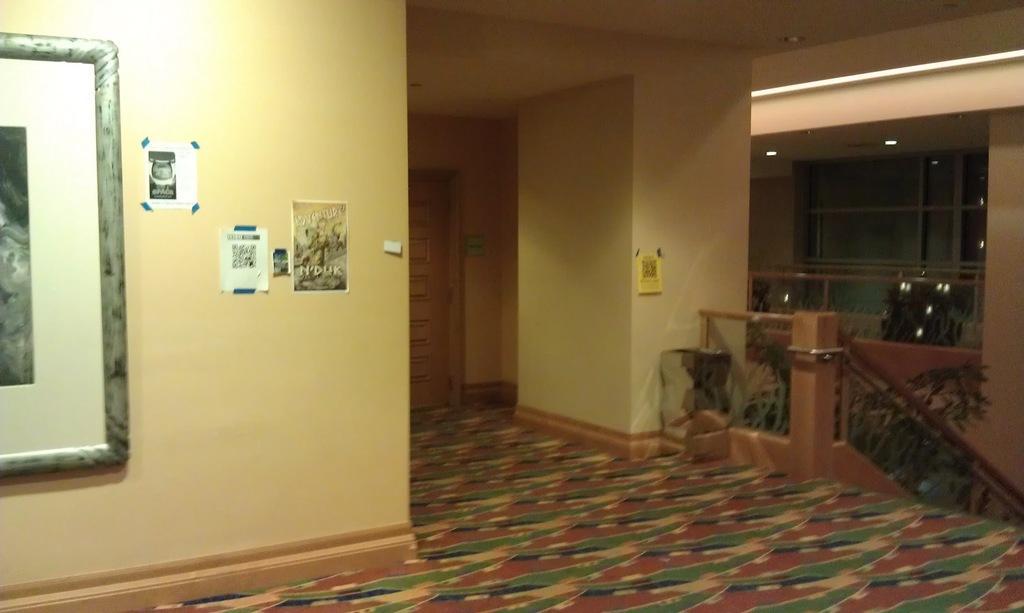In one or two sentences, can you explain what this image depicts? This image is taken from inside. In this image we can see there are some frames attached to the wall. On the right side of the image there are stairs, beside the stairs there are some plants. In the background there is a door attached to the wall. 